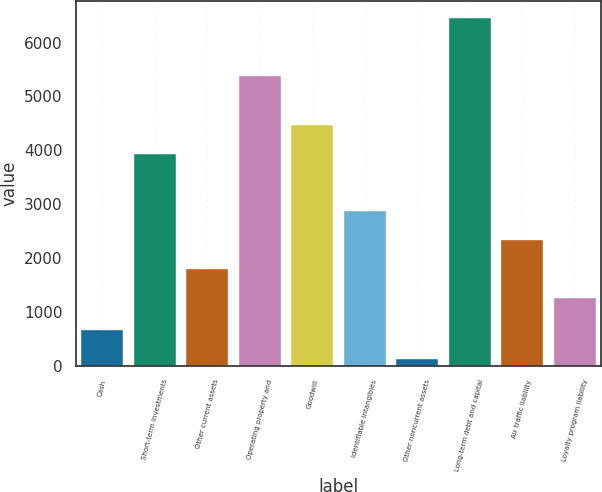Convert chart to OTSL. <chart><loc_0><loc_0><loc_500><loc_500><bar_chart><fcel>Cash<fcel>Short-term investments<fcel>Other current assets<fcel>Operating property and<fcel>Goodwill<fcel>Identifiable intangibles<fcel>Other noncurrent assets<fcel>Long-term debt and capital<fcel>Air traffic liability<fcel>Loyalty program liability<nl><fcel>660.6<fcel>3934<fcel>1791.6<fcel>5383<fcel>4469.6<fcel>2862.8<fcel>125<fcel>6454.2<fcel>2327.2<fcel>1256<nl></chart> 